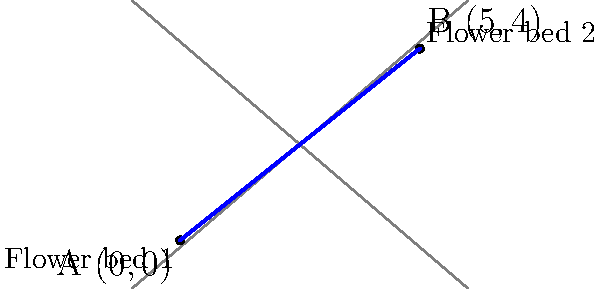In your meticulously planned garden, you have two circular flower beds. The center of the first flower bed is located at coordinates (0,0), while the center of the second flower bed is at (5,4). Using the distance formula, calculate the precise distance between the centers of these two flower beds. Round your answer to two decimal places. To solve this problem, we'll use the distance formula derived from the Pythagorean theorem:

$$d = \sqrt{(x_2 - x_1)^2 + (y_2 - y_1)^2}$$

Where $(x_1, y_1)$ are the coordinates of the first point and $(x_2, y_2)$ are the coordinates of the second point.

Step 1: Identify the coordinates
- Flower bed 1: $(x_1, y_1) = (0, 0)$
- Flower bed 2: $(x_2, y_2) = (5, 4)$

Step 2: Plug the coordinates into the distance formula
$$d = \sqrt{(5 - 0)^2 + (4 - 0)^2}$$

Step 3: Simplify the expressions inside the parentheses
$$d = \sqrt{5^2 + 4^2}$$

Step 4: Calculate the squares
$$d = \sqrt{25 + 16}$$

Step 5: Add the numbers under the square root
$$d = \sqrt{41}$$

Step 6: Calculate the square root and round to two decimal places
$$d \approx 6.40$$

Therefore, the distance between the centers of the two flower beds is approximately 6.40 units (which could represent feet or meters, depending on the scale of your garden plan).
Answer: 6.40 units 